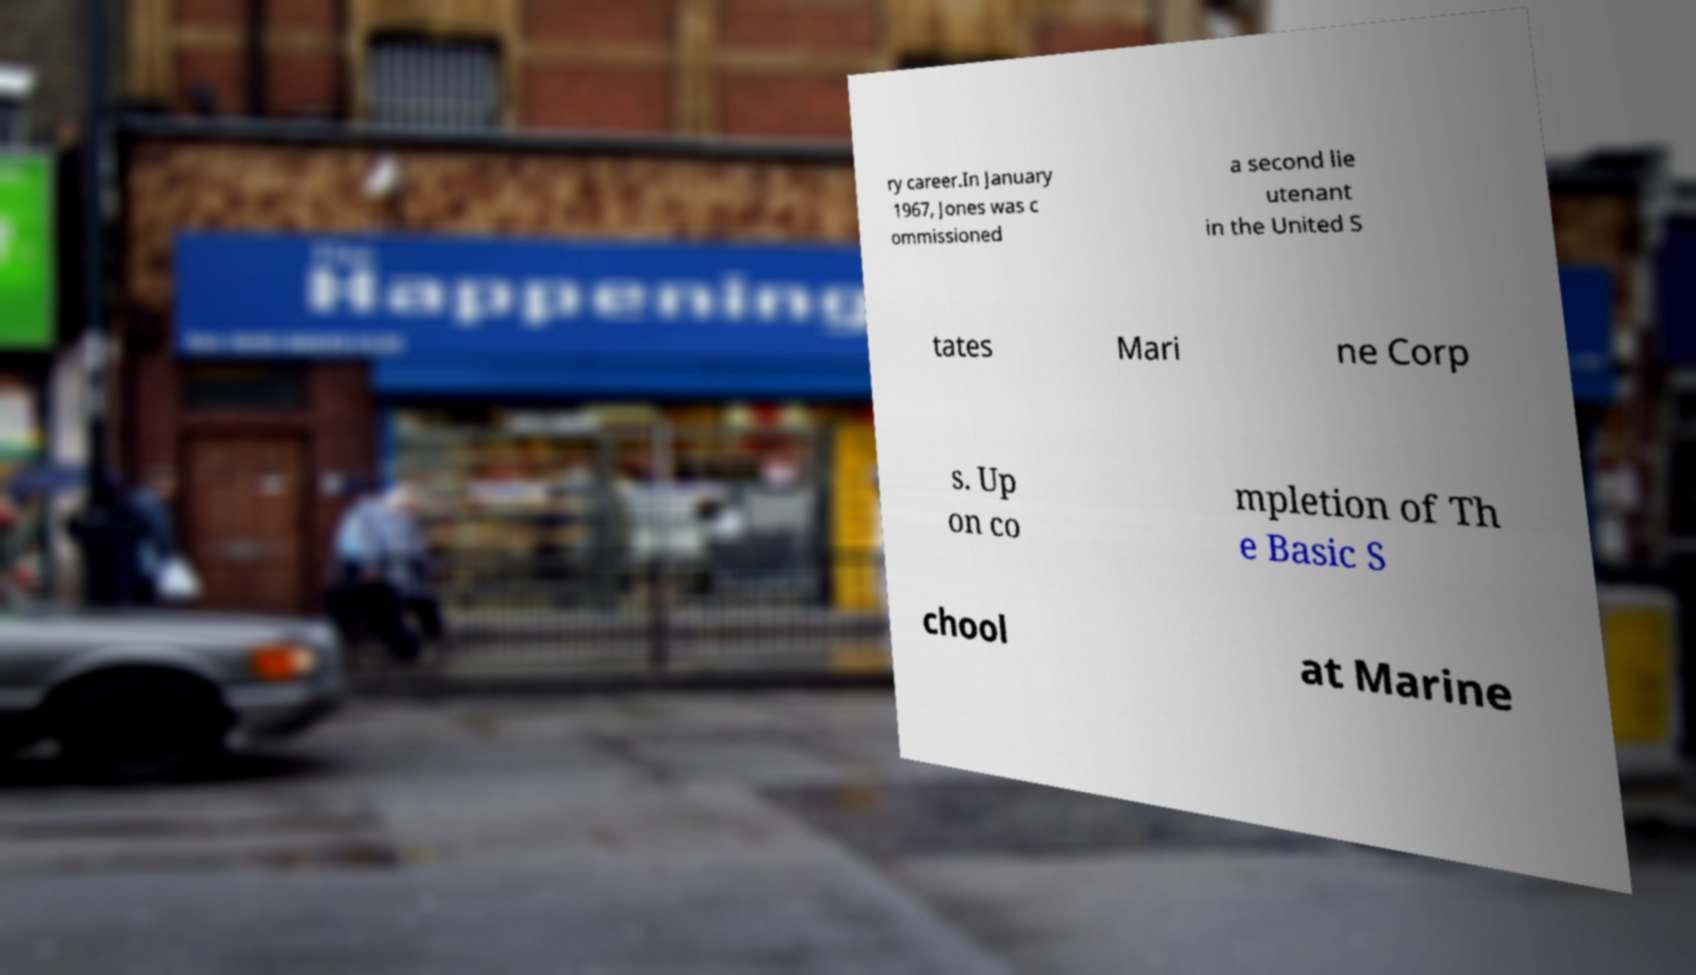For documentation purposes, I need the text within this image transcribed. Could you provide that? ry career.In January 1967, Jones was c ommissioned a second lie utenant in the United S tates Mari ne Corp s. Up on co mpletion of Th e Basic S chool at Marine 